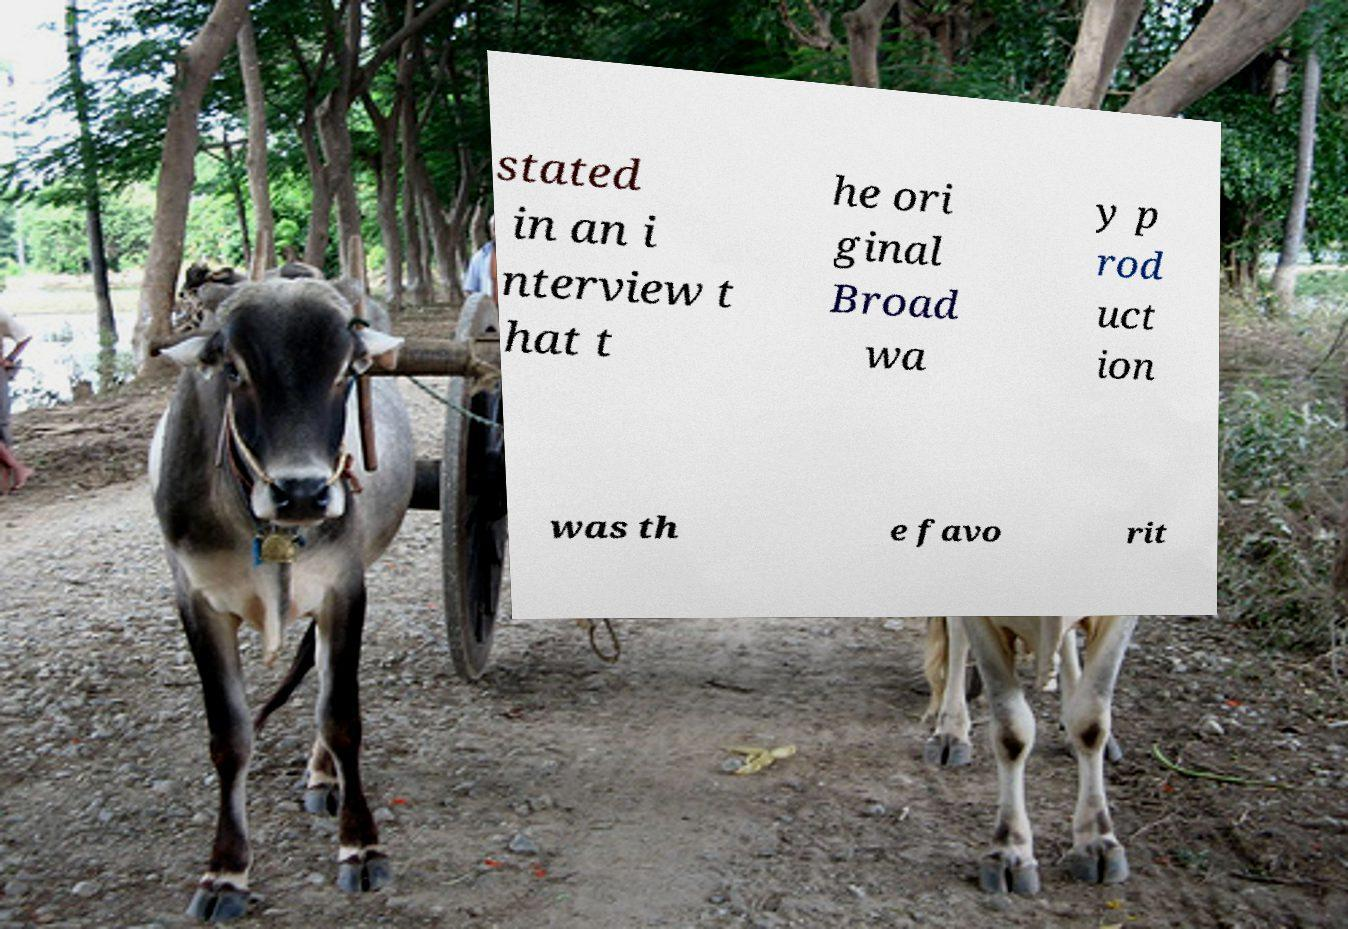I need the written content from this picture converted into text. Can you do that? stated in an i nterview t hat t he ori ginal Broad wa y p rod uct ion was th e favo rit 